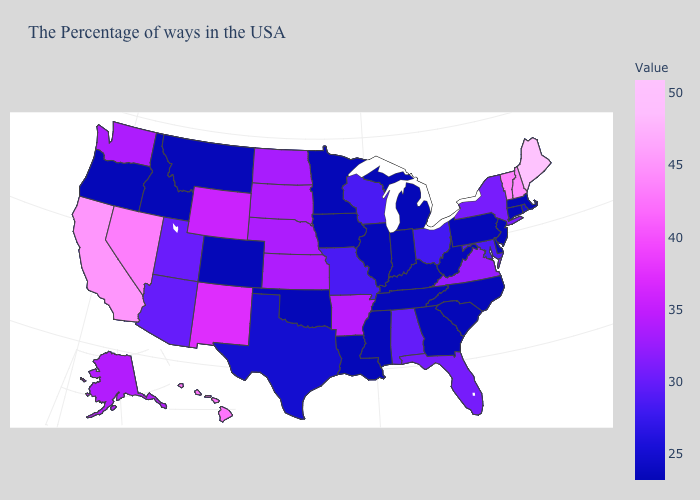Which states hav the highest value in the West?
Concise answer only. California. Which states have the highest value in the USA?
Be succinct. Maine. Among the states that border Pennsylvania , which have the highest value?
Concise answer only. New York. Does Alaska have the highest value in the USA?
Be succinct. No. Which states have the highest value in the USA?
Short answer required. Maine. 